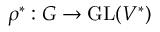Convert formula to latex. <formula><loc_0><loc_0><loc_500><loc_500>\rho ^ { * } \colon G \to { G L } ( V ^ { * } )</formula> 